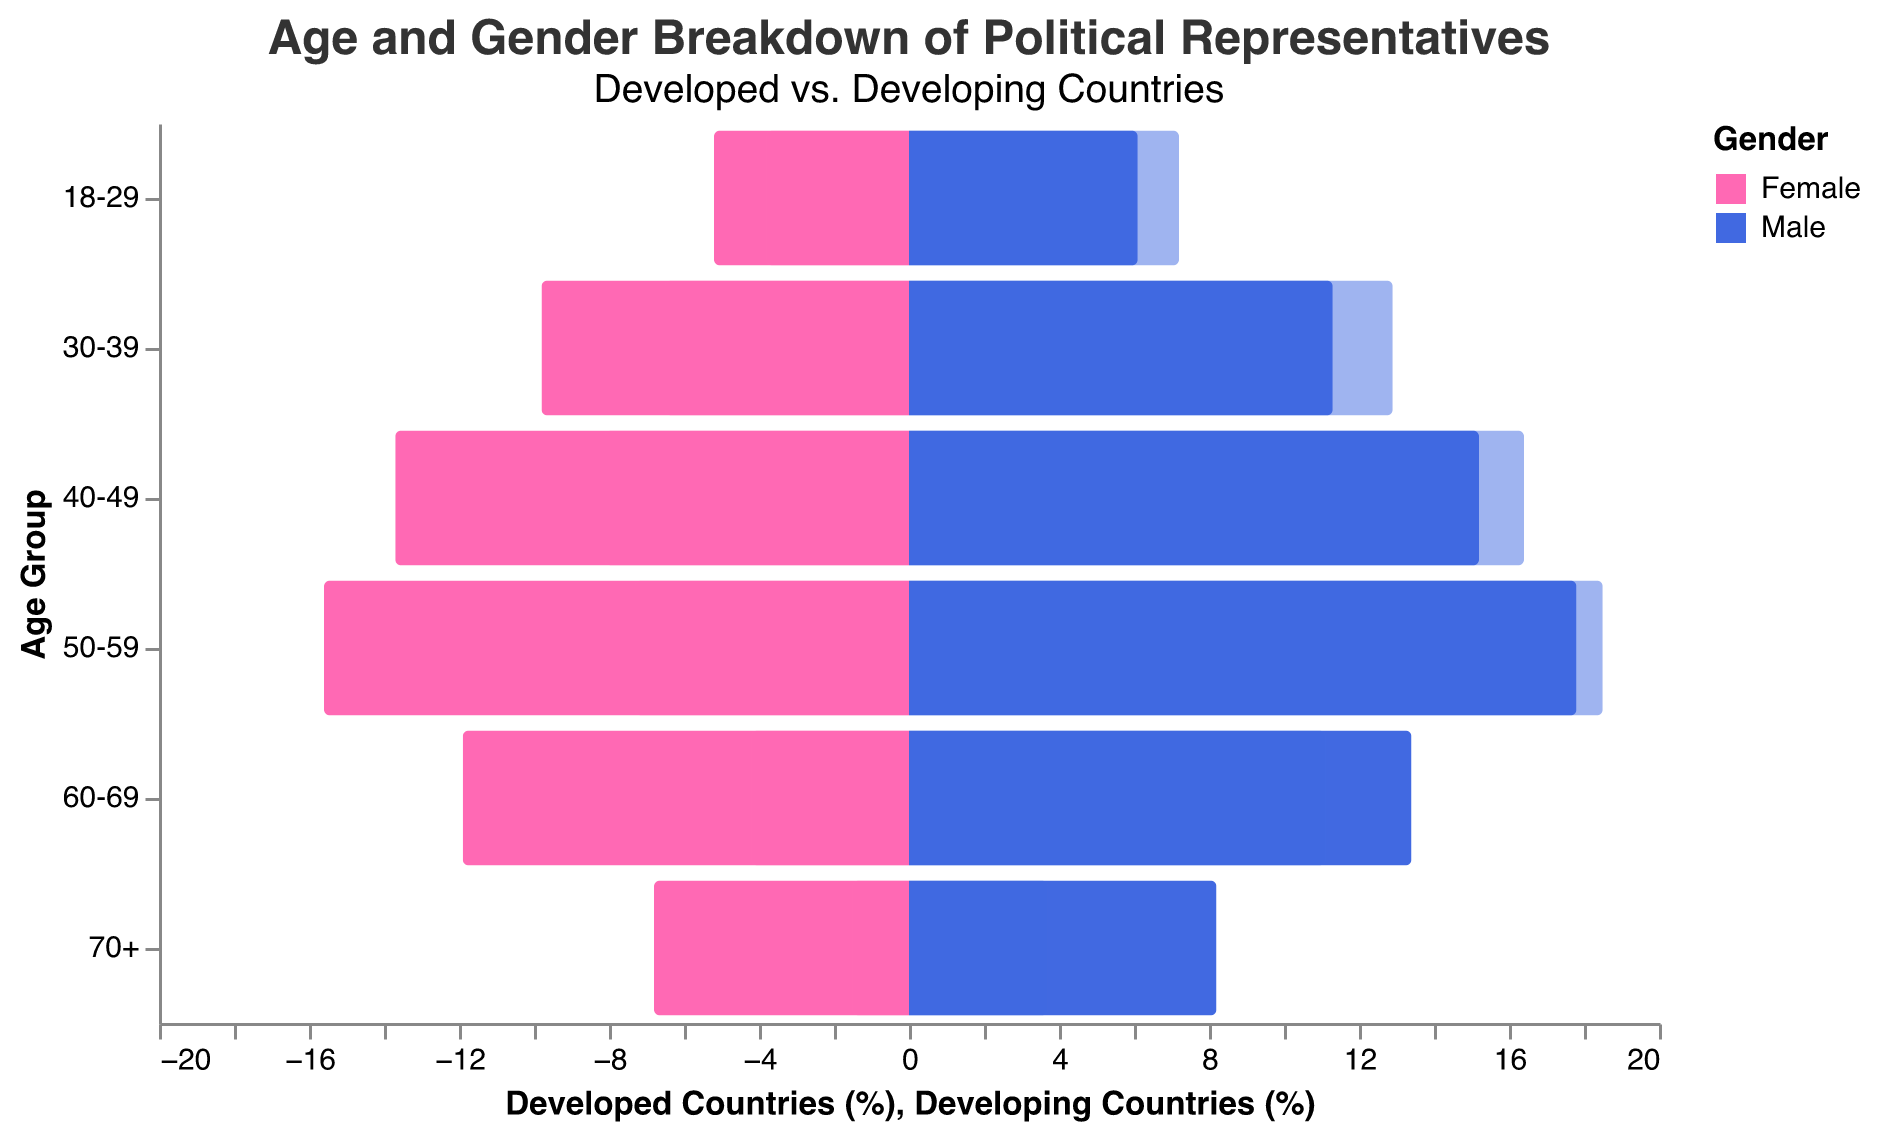What is the title of the figure? The title of the figure is displayed at the top. It reads "Age and Gender Breakdown of Political Representatives" with a subtitle "Developed vs. Developing Countries".
Answer: Age and Gender Breakdown of Political Representatives Which age group has the highest percentage of female political representatives in developed countries? By examining the left side of the pyramid for developed countries and looking for the highest bar among females, we can see that the age group 50-59 has the highest percentage of female political representatives, with 15.6%.
Answer: 50-59 In developing countries, how does the percentage of male political representatives aged 30-39 compare to the percentage of female political representatives aged 30-39? By looking at the right side for developing countries, the percentage for male political representatives aged 30-39 is 12.9%, and for females, it is 6.5%. Comparing these, we see that the percentage of male representatives is higher.
Answer: Higher What is the difference in the percentage of female political representatives aged 60-69 between developed and developing countries? The percentage for females aged 60-69 in developed countries is 11.9%, and in developing countries, it is 4.2%. The difference is calculated by subtracting the developing-country percentage from the developed-country percentage: 11.9% - 4.2% = 7.7%.
Answer: 7.7% What is the combined percentage of political representatives (both genders) aged 18-29 in developed countries? For developed countries, the percentages are 5.2% for females and 6.1% for males in the 18-29 age group. Adding these gives a total of 5.2% + 6.1% = 11.3%.
Answer: 11.3% In developed countries, how does the percentage of female political representatives aged 40-49 compare to male political representatives of the same age group? In the 40-49 age group for developed countries, the percentage for female representatives is 13.7% and for male representatives, it is 15.2%. Comparatively, the percentage of male representatives is higher.
Answer: Higher Which age group in developing countries has the lowest percentage of female political representatives? By looking at the right side of the pyramid for developing countries and identifying the shortest bar among females, the age group 70+ has the lowest percentage, with 1.5%.
Answer: 70+ Compare the percentage of male political representatives aged 50-59 between developed and developing countries. For the age group 50-59, in developed countries the percentage of male representatives is 17.8%, whereas in developing countries it is 18.5%. The percentage is higher in developing countries.
Answer: Higher in developing countries What is the average percentage of male political representatives aged 18-29 and 30-39 in developing countries? For developing countries, the percentages for male representatives aged 18-29 and 30-39 are 7.2% and 12.9%, respectively. The average is calculated by adding these percentages and dividing by 2: (7.2% + 12.9%) / 2 = 10.05%.
Answer: 10.05% What's the total percentage of political representatives (both genders) aged 70+ in developing countries? In developing countries, the percentages for the 70+ age group are 1.5% for females and 3.7% for males. Adding these gives a total of 1.5% + 3.7% = 5.2%.
Answer: 5.2% 